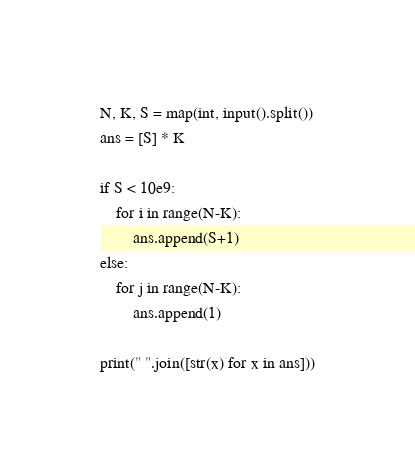Convert code to text. <code><loc_0><loc_0><loc_500><loc_500><_Python_>N, K, S = map(int, input().split())
ans = [S] * K

if S < 10e9:
    for i in range(N-K):
        ans.append(S+1)
else:
    for j in range(N-K):
        ans.append(1)

print(" ".join([str(x) for x in ans]))</code> 